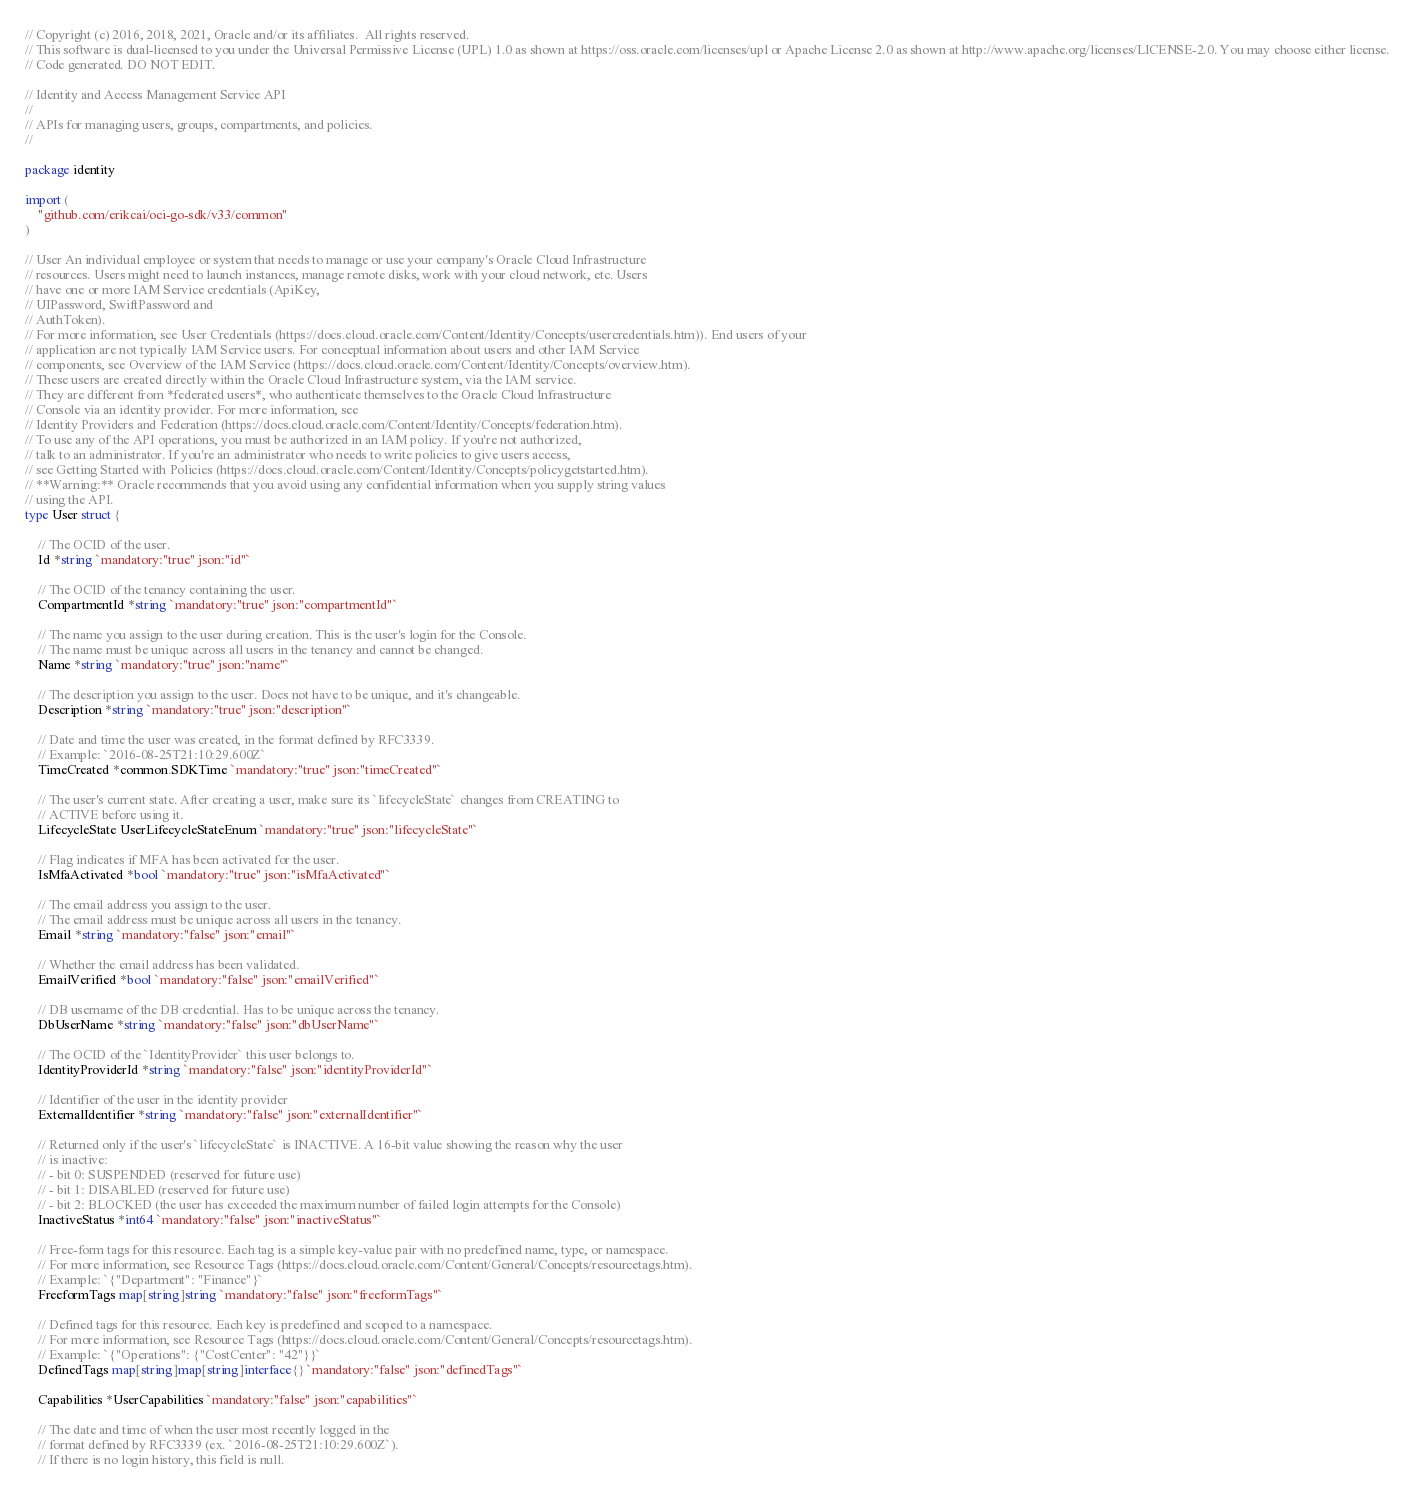<code> <loc_0><loc_0><loc_500><loc_500><_Go_>// Copyright (c) 2016, 2018, 2021, Oracle and/or its affiliates.  All rights reserved.
// This software is dual-licensed to you under the Universal Permissive License (UPL) 1.0 as shown at https://oss.oracle.com/licenses/upl or Apache License 2.0 as shown at http://www.apache.org/licenses/LICENSE-2.0. You may choose either license.
// Code generated. DO NOT EDIT.

// Identity and Access Management Service API
//
// APIs for managing users, groups, compartments, and policies.
//

package identity

import (
	"github.com/erikcai/oci-go-sdk/v33/common"
)

// User An individual employee or system that needs to manage or use your company's Oracle Cloud Infrastructure
// resources. Users might need to launch instances, manage remote disks, work with your cloud network, etc. Users
// have one or more IAM Service credentials (ApiKey,
// UIPassword, SwiftPassword and
// AuthToken).
// For more information, see User Credentials (https://docs.cloud.oracle.com/Content/Identity/Concepts/usercredentials.htm)). End users of your
// application are not typically IAM Service users. For conceptual information about users and other IAM Service
// components, see Overview of the IAM Service (https://docs.cloud.oracle.com/Content/Identity/Concepts/overview.htm).
// These users are created directly within the Oracle Cloud Infrastructure system, via the IAM service.
// They are different from *federated users*, who authenticate themselves to the Oracle Cloud Infrastructure
// Console via an identity provider. For more information, see
// Identity Providers and Federation (https://docs.cloud.oracle.com/Content/Identity/Concepts/federation.htm).
// To use any of the API operations, you must be authorized in an IAM policy. If you're not authorized,
// talk to an administrator. If you're an administrator who needs to write policies to give users access,
// see Getting Started with Policies (https://docs.cloud.oracle.com/Content/Identity/Concepts/policygetstarted.htm).
// **Warning:** Oracle recommends that you avoid using any confidential information when you supply string values
// using the API.
type User struct {

	// The OCID of the user.
	Id *string `mandatory:"true" json:"id"`

	// The OCID of the tenancy containing the user.
	CompartmentId *string `mandatory:"true" json:"compartmentId"`

	// The name you assign to the user during creation. This is the user's login for the Console.
	// The name must be unique across all users in the tenancy and cannot be changed.
	Name *string `mandatory:"true" json:"name"`

	// The description you assign to the user. Does not have to be unique, and it's changeable.
	Description *string `mandatory:"true" json:"description"`

	// Date and time the user was created, in the format defined by RFC3339.
	// Example: `2016-08-25T21:10:29.600Z`
	TimeCreated *common.SDKTime `mandatory:"true" json:"timeCreated"`

	// The user's current state. After creating a user, make sure its `lifecycleState` changes from CREATING to
	// ACTIVE before using it.
	LifecycleState UserLifecycleStateEnum `mandatory:"true" json:"lifecycleState"`

	// Flag indicates if MFA has been activated for the user.
	IsMfaActivated *bool `mandatory:"true" json:"isMfaActivated"`

	// The email address you assign to the user.
	// The email address must be unique across all users in the tenancy.
	Email *string `mandatory:"false" json:"email"`

	// Whether the email address has been validated.
	EmailVerified *bool `mandatory:"false" json:"emailVerified"`

	// DB username of the DB credential. Has to be unique across the tenancy.
	DbUserName *string `mandatory:"false" json:"dbUserName"`

	// The OCID of the `IdentityProvider` this user belongs to.
	IdentityProviderId *string `mandatory:"false" json:"identityProviderId"`

	// Identifier of the user in the identity provider
	ExternalIdentifier *string `mandatory:"false" json:"externalIdentifier"`

	// Returned only if the user's `lifecycleState` is INACTIVE. A 16-bit value showing the reason why the user
	// is inactive:
	// - bit 0: SUSPENDED (reserved for future use)
	// - bit 1: DISABLED (reserved for future use)
	// - bit 2: BLOCKED (the user has exceeded the maximum number of failed login attempts for the Console)
	InactiveStatus *int64 `mandatory:"false" json:"inactiveStatus"`

	// Free-form tags for this resource. Each tag is a simple key-value pair with no predefined name, type, or namespace.
	// For more information, see Resource Tags (https://docs.cloud.oracle.com/Content/General/Concepts/resourcetags.htm).
	// Example: `{"Department": "Finance"}`
	FreeformTags map[string]string `mandatory:"false" json:"freeformTags"`

	// Defined tags for this resource. Each key is predefined and scoped to a namespace.
	// For more information, see Resource Tags (https://docs.cloud.oracle.com/Content/General/Concepts/resourcetags.htm).
	// Example: `{"Operations": {"CostCenter": "42"}}`
	DefinedTags map[string]map[string]interface{} `mandatory:"false" json:"definedTags"`

	Capabilities *UserCapabilities `mandatory:"false" json:"capabilities"`

	// The date and time of when the user most recently logged in the
	// format defined by RFC3339 (ex. `2016-08-25T21:10:29.600Z`).
	// If there is no login history, this field is null.</code> 